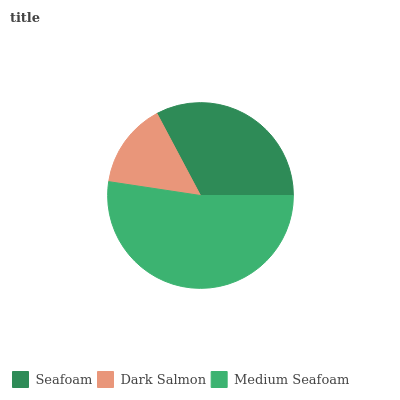Is Dark Salmon the minimum?
Answer yes or no. Yes. Is Medium Seafoam the maximum?
Answer yes or no. Yes. Is Medium Seafoam the minimum?
Answer yes or no. No. Is Dark Salmon the maximum?
Answer yes or no. No. Is Medium Seafoam greater than Dark Salmon?
Answer yes or no. Yes. Is Dark Salmon less than Medium Seafoam?
Answer yes or no. Yes. Is Dark Salmon greater than Medium Seafoam?
Answer yes or no. No. Is Medium Seafoam less than Dark Salmon?
Answer yes or no. No. Is Seafoam the high median?
Answer yes or no. Yes. Is Seafoam the low median?
Answer yes or no. Yes. Is Dark Salmon the high median?
Answer yes or no. No. Is Dark Salmon the low median?
Answer yes or no. No. 